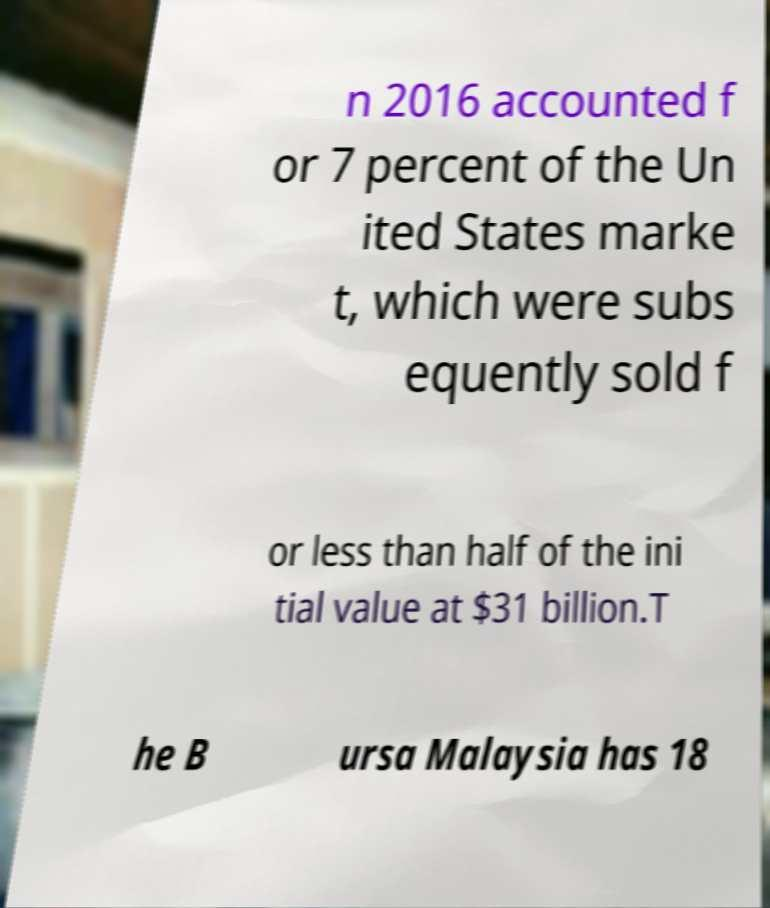Can you read and provide the text displayed in the image?This photo seems to have some interesting text. Can you extract and type it out for me? n 2016 accounted f or 7 percent of the Un ited States marke t, which were subs equently sold f or less than half of the ini tial value at $31 billion.T he B ursa Malaysia has 18 